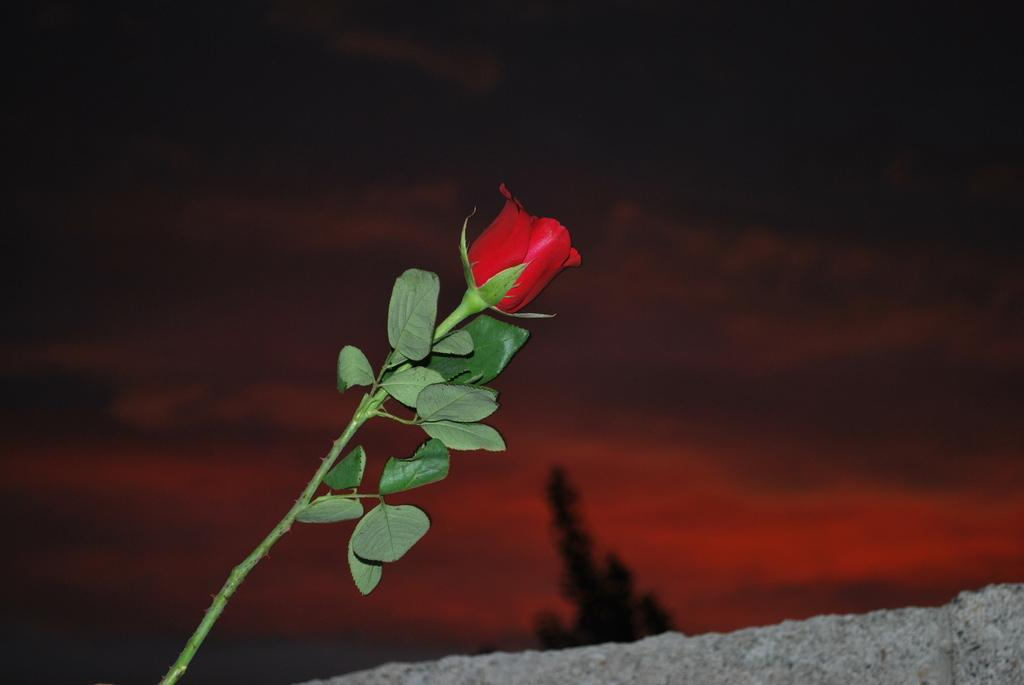What type of flower is on the plant in the image? There is a red rose flower on a plant in the image. What can be seen at the bottom of the image? There is a stone at the bottom of the image. What is visible in the background of the image? There is a tree and clouds visible in the sky in the background of the image. What type of mine is visible in the image? There is no mine present in the image. What direction is the air blowing in the image? The image does not provide information about the direction of the air. 